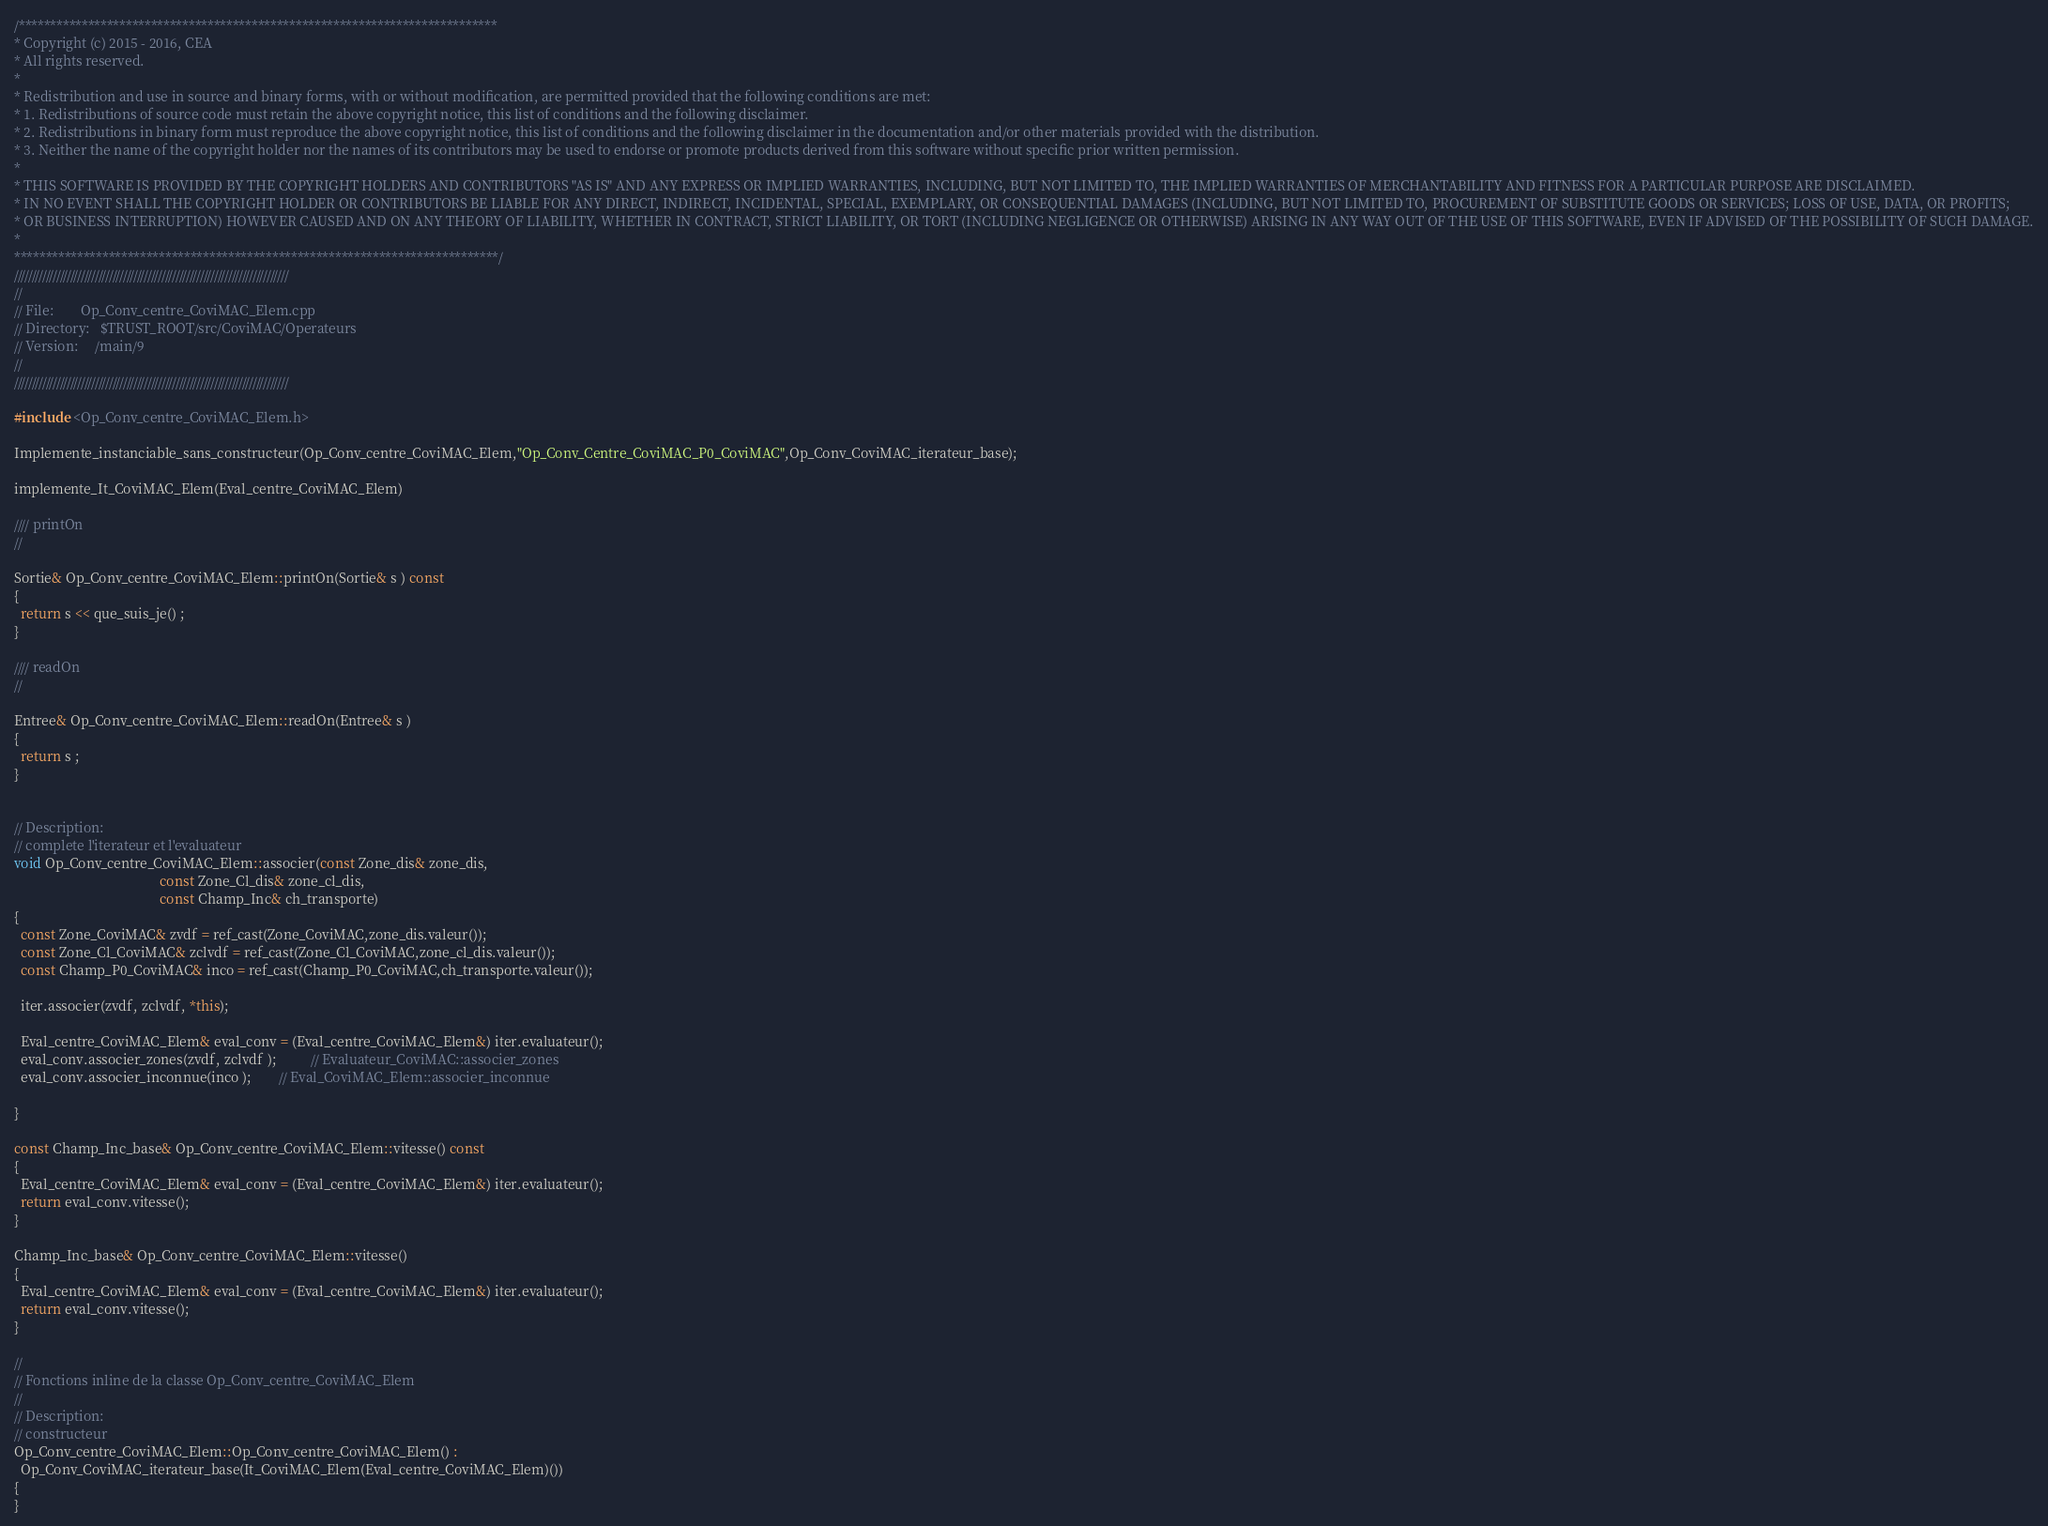Convert code to text. <code><loc_0><loc_0><loc_500><loc_500><_C++_>/****************************************************************************
* Copyright (c) 2015 - 2016, CEA
* All rights reserved.
*
* Redistribution and use in source and binary forms, with or without modification, are permitted provided that the following conditions are met:
* 1. Redistributions of source code must retain the above copyright notice, this list of conditions and the following disclaimer.
* 2. Redistributions in binary form must reproduce the above copyright notice, this list of conditions and the following disclaimer in the documentation and/or other materials provided with the distribution.
* 3. Neither the name of the copyright holder nor the names of its contributors may be used to endorse or promote products derived from this software without specific prior written permission.
*
* THIS SOFTWARE IS PROVIDED BY THE COPYRIGHT HOLDERS AND CONTRIBUTORS "AS IS" AND ANY EXPRESS OR IMPLIED WARRANTIES, INCLUDING, BUT NOT LIMITED TO, THE IMPLIED WARRANTIES OF MERCHANTABILITY AND FITNESS FOR A PARTICULAR PURPOSE ARE DISCLAIMED.
* IN NO EVENT SHALL THE COPYRIGHT HOLDER OR CONTRIBUTORS BE LIABLE FOR ANY DIRECT, INDIRECT, INCIDENTAL, SPECIAL, EXEMPLARY, OR CONSEQUENTIAL DAMAGES (INCLUDING, BUT NOT LIMITED TO, PROCUREMENT OF SUBSTITUTE GOODS OR SERVICES; LOSS OF USE, DATA, OR PROFITS;
* OR BUSINESS INTERRUPTION) HOWEVER CAUSED AND ON ANY THEORY OF LIABILITY, WHETHER IN CONTRACT, STRICT LIABILITY, OR TORT (INCLUDING NEGLIGENCE OR OTHERWISE) ARISING IN ANY WAY OUT OF THE USE OF THIS SOFTWARE, EVEN IF ADVISED OF THE POSSIBILITY OF SUCH DAMAGE.
*
*****************************************************************************/
//////////////////////////////////////////////////////////////////////////////
//
// File:        Op_Conv_centre_CoviMAC_Elem.cpp
// Directory:   $TRUST_ROOT/src/CoviMAC/Operateurs
// Version:     /main/9
//
//////////////////////////////////////////////////////////////////////////////

#include <Op_Conv_centre_CoviMAC_Elem.h>

Implemente_instanciable_sans_constructeur(Op_Conv_centre_CoviMAC_Elem,"Op_Conv_Centre_CoviMAC_P0_CoviMAC",Op_Conv_CoviMAC_iterateur_base);

implemente_It_CoviMAC_Elem(Eval_centre_CoviMAC_Elem)

//// printOn
//

Sortie& Op_Conv_centre_CoviMAC_Elem::printOn(Sortie& s ) const
{
  return s << que_suis_je() ;
}

//// readOn
//

Entree& Op_Conv_centre_CoviMAC_Elem::readOn(Entree& s )
{
  return s ;
}


// Description:
// complete l'iterateur et l'evaluateur
void Op_Conv_centre_CoviMAC_Elem::associer(const Zone_dis& zone_dis,
                                           const Zone_Cl_dis& zone_cl_dis,
                                           const Champ_Inc& ch_transporte)
{
  const Zone_CoviMAC& zvdf = ref_cast(Zone_CoviMAC,zone_dis.valeur());
  const Zone_Cl_CoviMAC& zclvdf = ref_cast(Zone_Cl_CoviMAC,zone_cl_dis.valeur());
  const Champ_P0_CoviMAC& inco = ref_cast(Champ_P0_CoviMAC,ch_transporte.valeur());

  iter.associer(zvdf, zclvdf, *this);

  Eval_centre_CoviMAC_Elem& eval_conv = (Eval_centre_CoviMAC_Elem&) iter.evaluateur();
  eval_conv.associer_zones(zvdf, zclvdf );          // Evaluateur_CoviMAC::associer_zones
  eval_conv.associer_inconnue(inco );        // Eval_CoviMAC_Elem::associer_inconnue

}

const Champ_Inc_base& Op_Conv_centre_CoviMAC_Elem::vitesse() const
{
  Eval_centre_CoviMAC_Elem& eval_conv = (Eval_centre_CoviMAC_Elem&) iter.evaluateur();
  return eval_conv.vitesse();
}

Champ_Inc_base& Op_Conv_centre_CoviMAC_Elem::vitesse()
{
  Eval_centre_CoviMAC_Elem& eval_conv = (Eval_centre_CoviMAC_Elem&) iter.evaluateur();
  return eval_conv.vitesse();
}

//
// Fonctions inline de la classe Op_Conv_centre_CoviMAC_Elem
//
// Description:
// constructeur
Op_Conv_centre_CoviMAC_Elem::Op_Conv_centre_CoviMAC_Elem() :
  Op_Conv_CoviMAC_iterateur_base(It_CoviMAC_Elem(Eval_centre_CoviMAC_Elem)())
{
}
</code> 